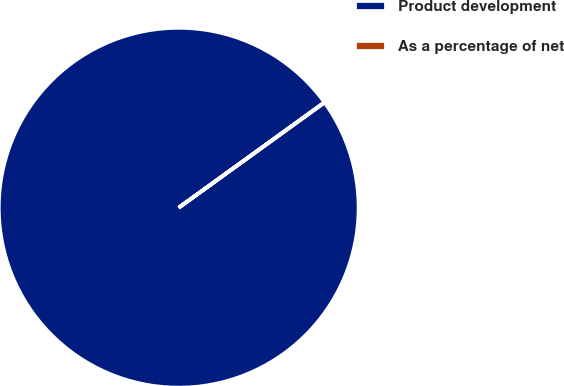<chart> <loc_0><loc_0><loc_500><loc_500><pie_chart><fcel>Product development<fcel>As a percentage of net<nl><fcel>100.0%<fcel>0.0%<nl></chart> 